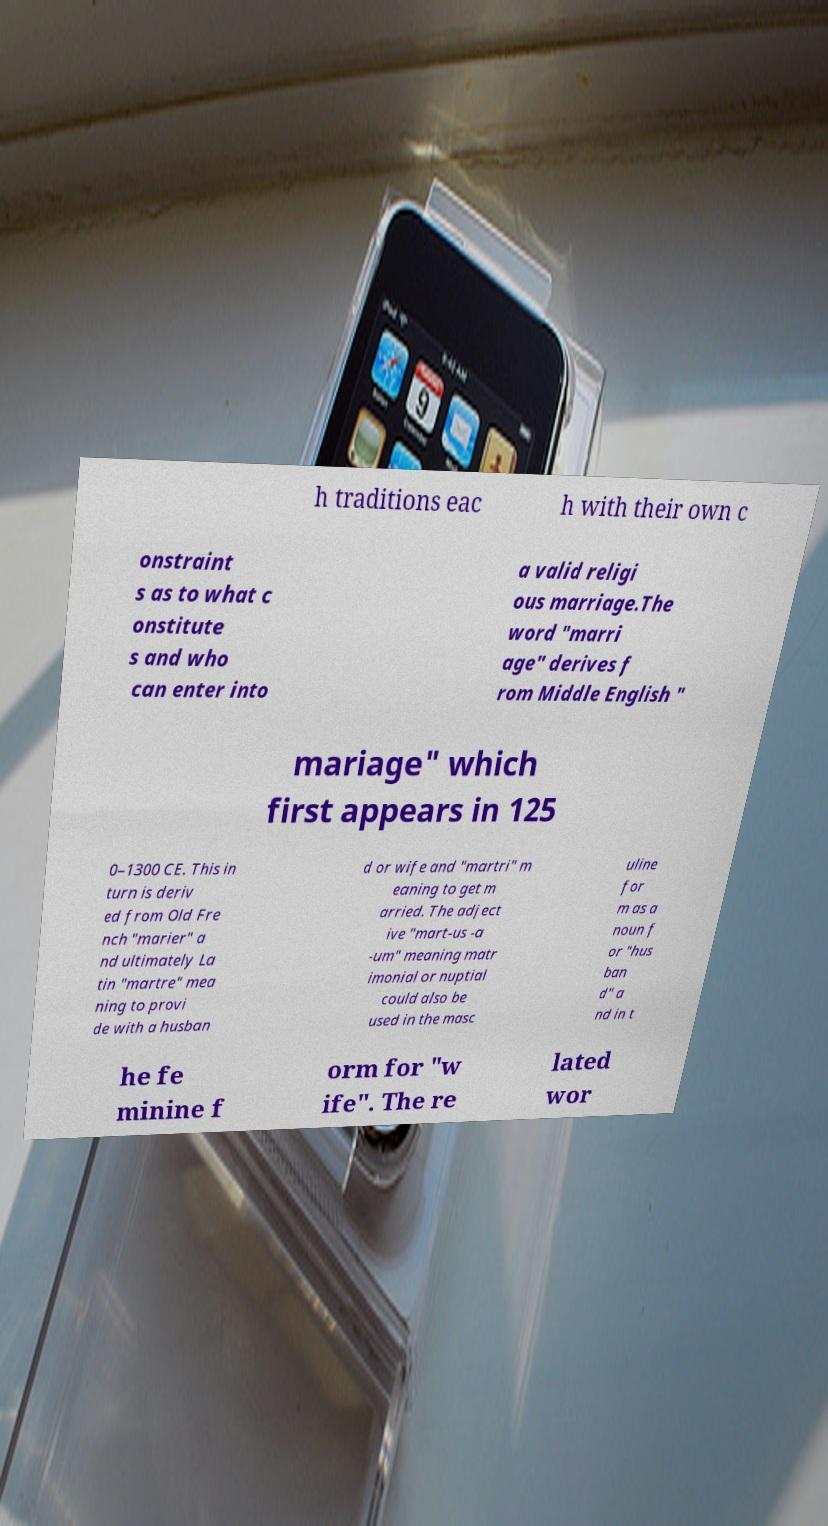Could you extract and type out the text from this image? h traditions eac h with their own c onstraint s as to what c onstitute s and who can enter into a valid religi ous marriage.The word "marri age" derives f rom Middle English " mariage" which first appears in 125 0–1300 CE. This in turn is deriv ed from Old Fre nch "marier" a nd ultimately La tin "martre" mea ning to provi de with a husban d or wife and "martri" m eaning to get m arried. The adject ive "mart-us -a -um" meaning matr imonial or nuptial could also be used in the masc uline for m as a noun f or "hus ban d" a nd in t he fe minine f orm for "w ife". The re lated wor 